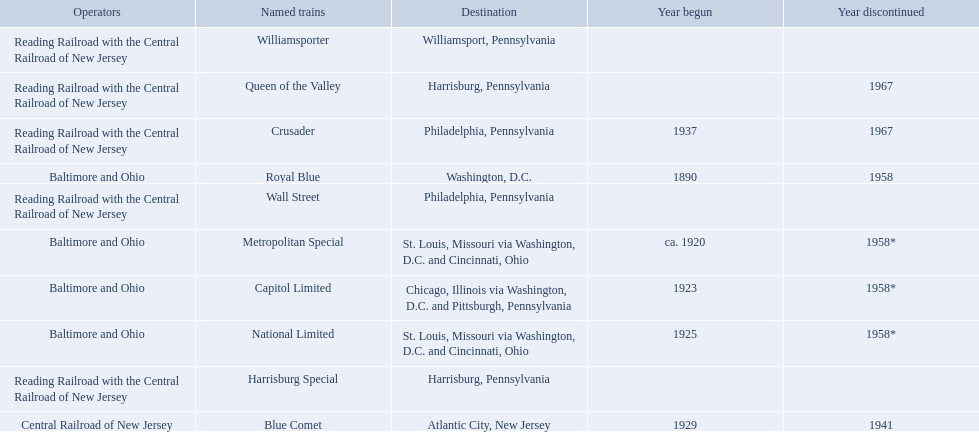What destinations are listed from the central railroad of new jersey terminal? Chicago, Illinois via Washington, D.C. and Pittsburgh, Pennsylvania, St. Louis, Missouri via Washington, D.C. and Cincinnati, Ohio, St. Louis, Missouri via Washington, D.C. and Cincinnati, Ohio, Washington, D.C., Atlantic City, New Jersey, Philadelphia, Pennsylvania, Harrisburg, Pennsylvania, Harrisburg, Pennsylvania, Philadelphia, Pennsylvania, Williamsport, Pennsylvania. Which of these destinations is listed first? Chicago, Illinois via Washington, D.C. and Pittsburgh, Pennsylvania. 